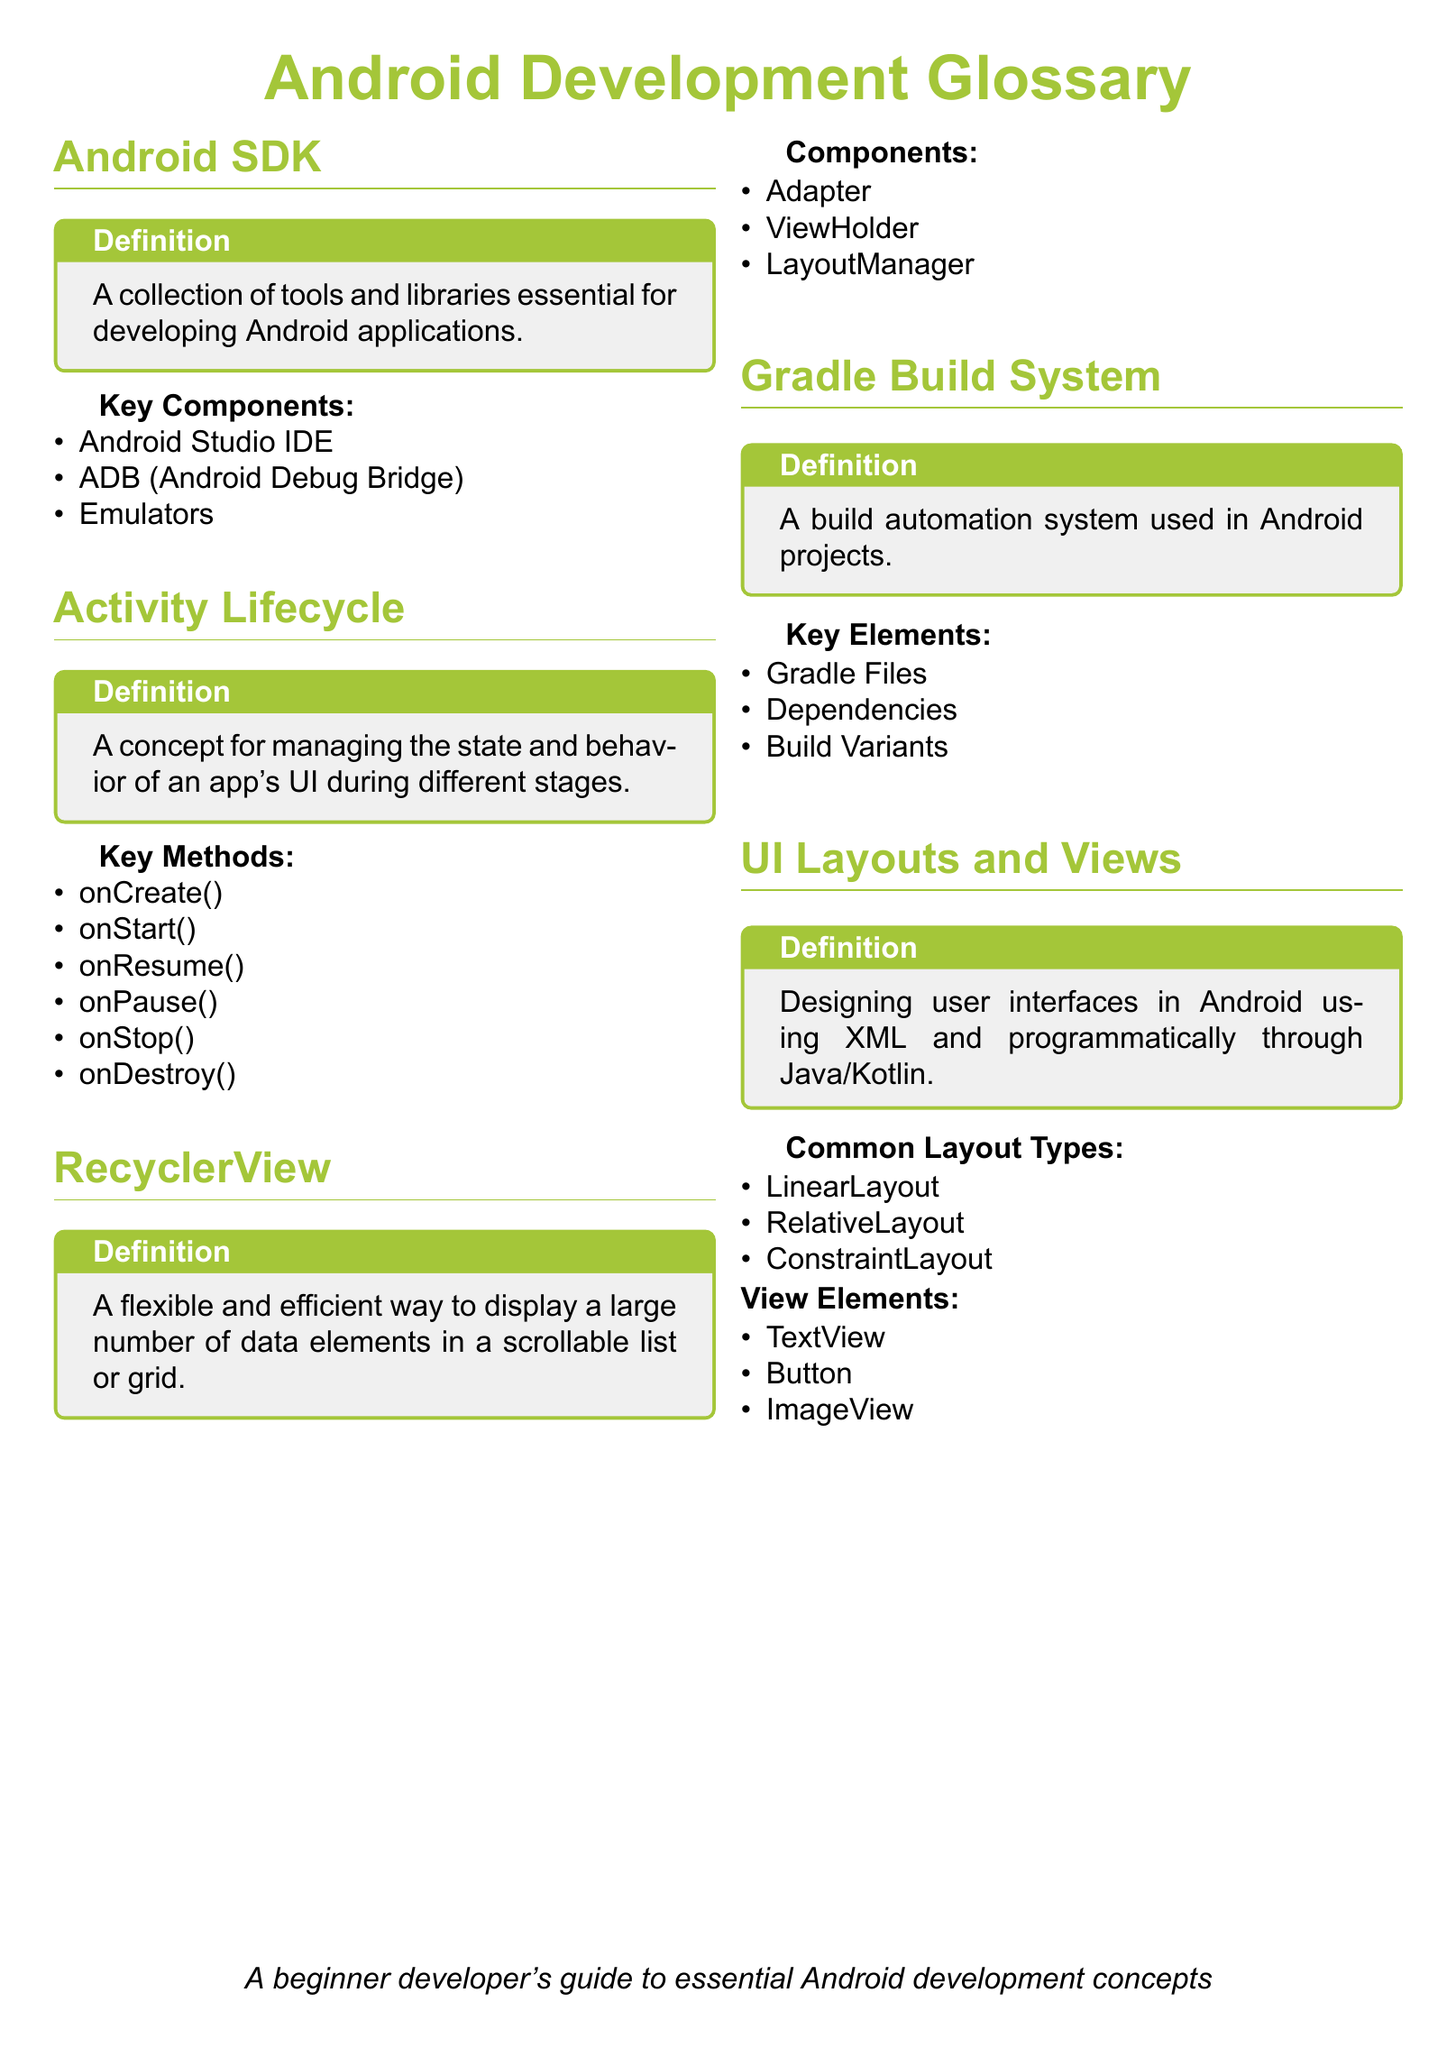What is the definition of Android SDK? The definition of Android SDK is provided in the document as "A collection of tools and libraries essential for developing Android applications."
Answer: A collection of tools and libraries essential for developing Android applications How many key methods are listed under Activity Lifecycle? The document mentions the key methods under Activity Lifecycle, which are listed in a bullet format. Counting those gives a total of six methods.
Answer: Six What is a RecyclerView? The definition of RecyclerView in the document states it is "A flexible and efficient way to display a large number of data elements in a scrollable list or grid."
Answer: A flexible and efficient way to display a large number of data elements in a scrollable list or grid What are the common layout types mentioned? The document lists three common layout types in UI Layouts and Views. These are written in bullet points. Thus, the answer is "LinearLayout, RelativeLayout, ConstraintLayout."
Answer: LinearLayout, RelativeLayout, ConstraintLayout What does Gradle Build System refer to? The document defines Gradle Build System as "A build automation system used in Android projects."
Answer: A build automation system used in Android projects How many key components are identified in Android SDK? The document includes a bullet point list under Android SDK, which shows three key components.
Answer: Three 